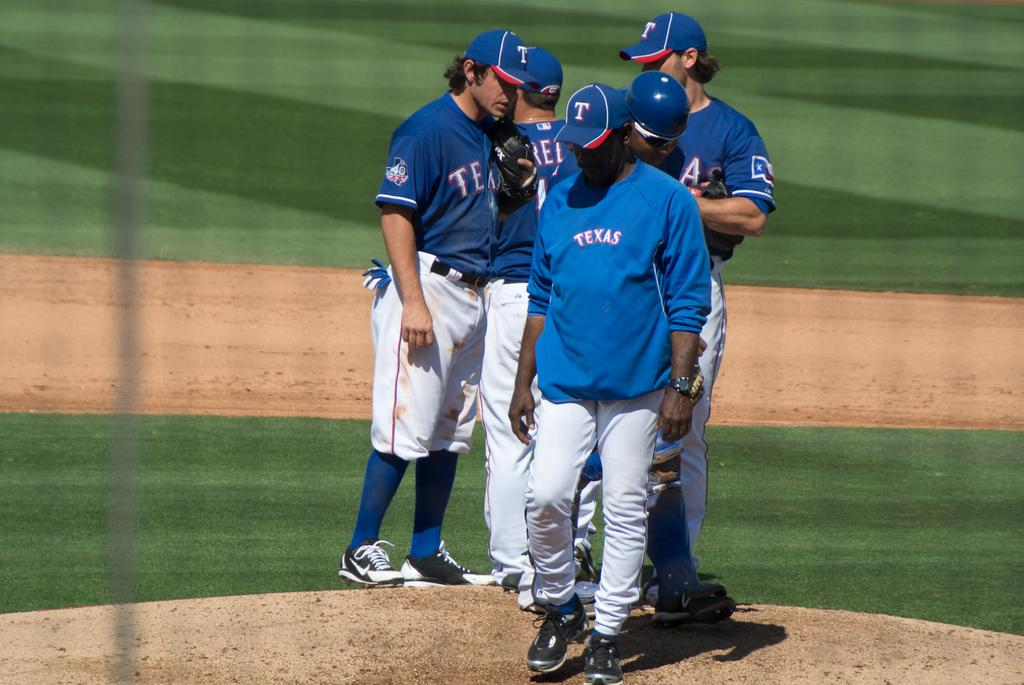<image>
Write a terse but informative summary of the picture. some Texas players gathered at the mound on the field 